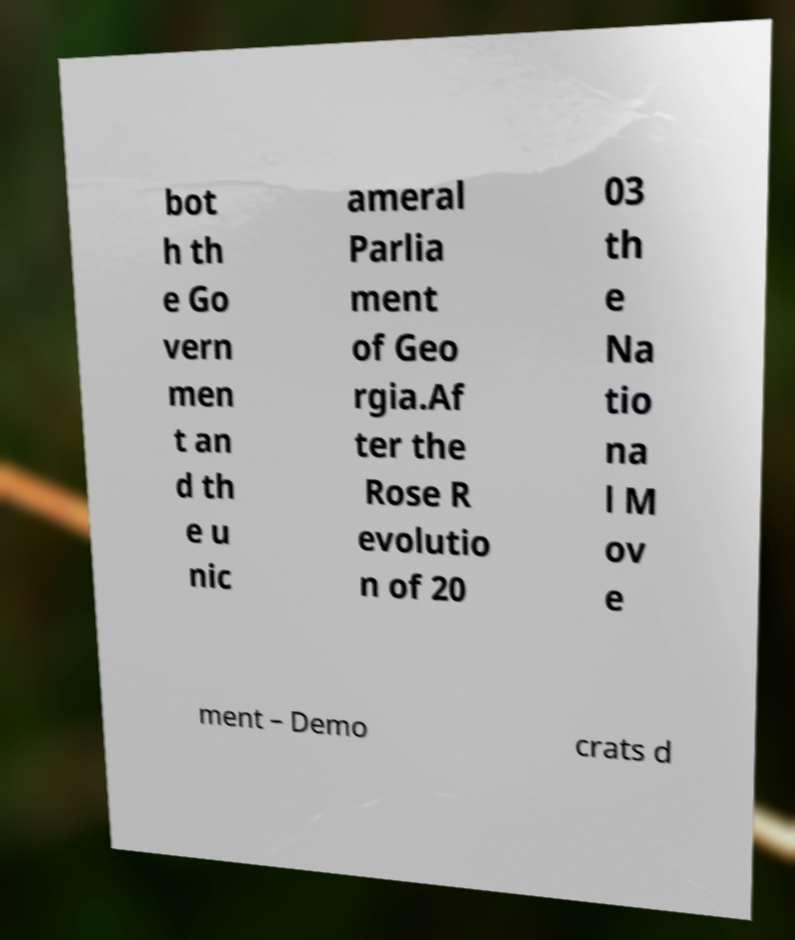I need the written content from this picture converted into text. Can you do that? bot h th e Go vern men t an d th e u nic ameral Parlia ment of Geo rgia.Af ter the Rose R evolutio n of 20 03 th e Na tio na l M ov e ment – Demo crats d 